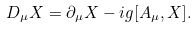<formula> <loc_0><loc_0><loc_500><loc_500>D _ { \mu } X = \partial _ { \mu } X - i g [ A _ { \mu } , X ] .</formula> 